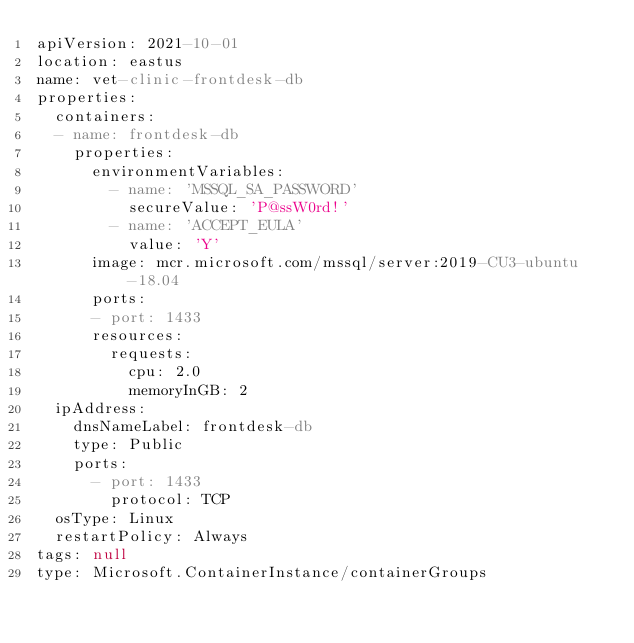Convert code to text. <code><loc_0><loc_0><loc_500><loc_500><_YAML_>apiVersion: 2021-10-01
location: eastus
name: vet-clinic-frontdesk-db
properties:
  containers:
  - name: frontdesk-db
    properties:
      environmentVariables:
        - name: 'MSSQL_SA_PASSWORD'
          secureValue: 'P@ssW0rd!'
        - name: 'ACCEPT_EULA'
          value: 'Y'
      image: mcr.microsoft.com/mssql/server:2019-CU3-ubuntu-18.04
      ports:
      - port: 1433
      resources:
        requests:
          cpu: 2.0
          memoryInGB: 2
  ipAddress:
    dnsNameLabel: frontdesk-db
    type: Public
    ports:
      - port: 1433
        protocol: TCP
  osType: Linux
  restartPolicy: Always
tags: null
type: Microsoft.ContainerInstance/containerGroups</code> 